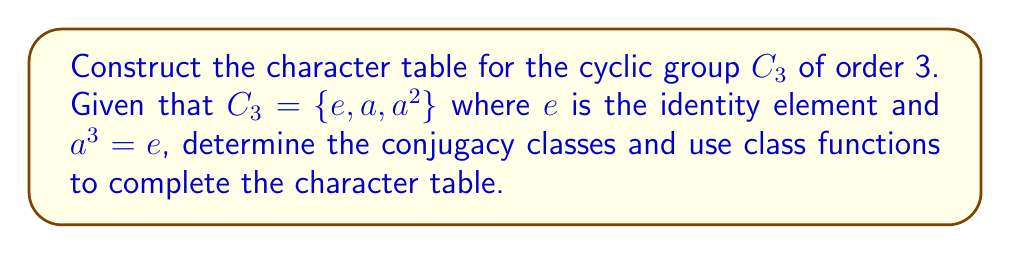Can you solve this math problem? Let's approach this step-by-step:

1. Determine the conjugacy classes:
   In $C_3$, each element forms its own conjugacy class because the group is abelian.
   Conjugacy classes: $\{e\}$, $\{a\}$, $\{a^2\}$

2. Determine the number of irreducible representations:
   The number of irreducible representations equals the number of conjugacy classes, which is 3.

3. Determine the dimensions of the irreducible representations:
   For a group of order 3, the possible dimensions $d_i$ must satisfy:
   $$\sum_{i=1}^3 d_i^2 = 3$$
   The only solution is $1^2 + 1^2 + 1^2 = 3$, so all irreducible representations are 1-dimensional.

4. Construct the character table:
   - The first row is always all 1's (trivial representation).
   - For the other two rows, we need to find two more 1-dimensional representations.
   - Let $\omega = e^{2\pi i/3}$ be a primitive cube root of unity.
   - The character values for $a$ in the two non-trivial representations will be $\omega$ and $\omega^2$.

5. Complete the character table:

   $$\begin{array}{c|ccc}
      C_3 & \{e\} & \{a\} & \{a^2\} \\
      \hline
      \chi_1 & 1 & 1 & 1 \\
      \chi_2 & 1 & \omega & \omega^2 \\
      \chi_3 & 1 & \omega^2 & \omega
   \end{array}$$

   Where $\omega = e^{2\pi i/3} = -\frac{1}{2} + i\frac{\sqrt{3}}{2}$

6. Verify orthogonality relations:
   - The columns are orthogonal when viewed as vectors.
   - The rows are orthogonal when each entry is multiplied by the size of the corresponding conjugacy class.
Answer: $$\begin{array}{c|ccc}
   C_3 & \{e\} & \{a\} & \{a^2\} \\
   \hline
   \chi_1 & 1 & 1 & 1 \\
   \chi_2 & 1 & \omega & \omega^2 \\
   \chi_3 & 1 & \omega^2 & \omega
\end{array}$$
Where $\omega = e^{2\pi i/3}$ 